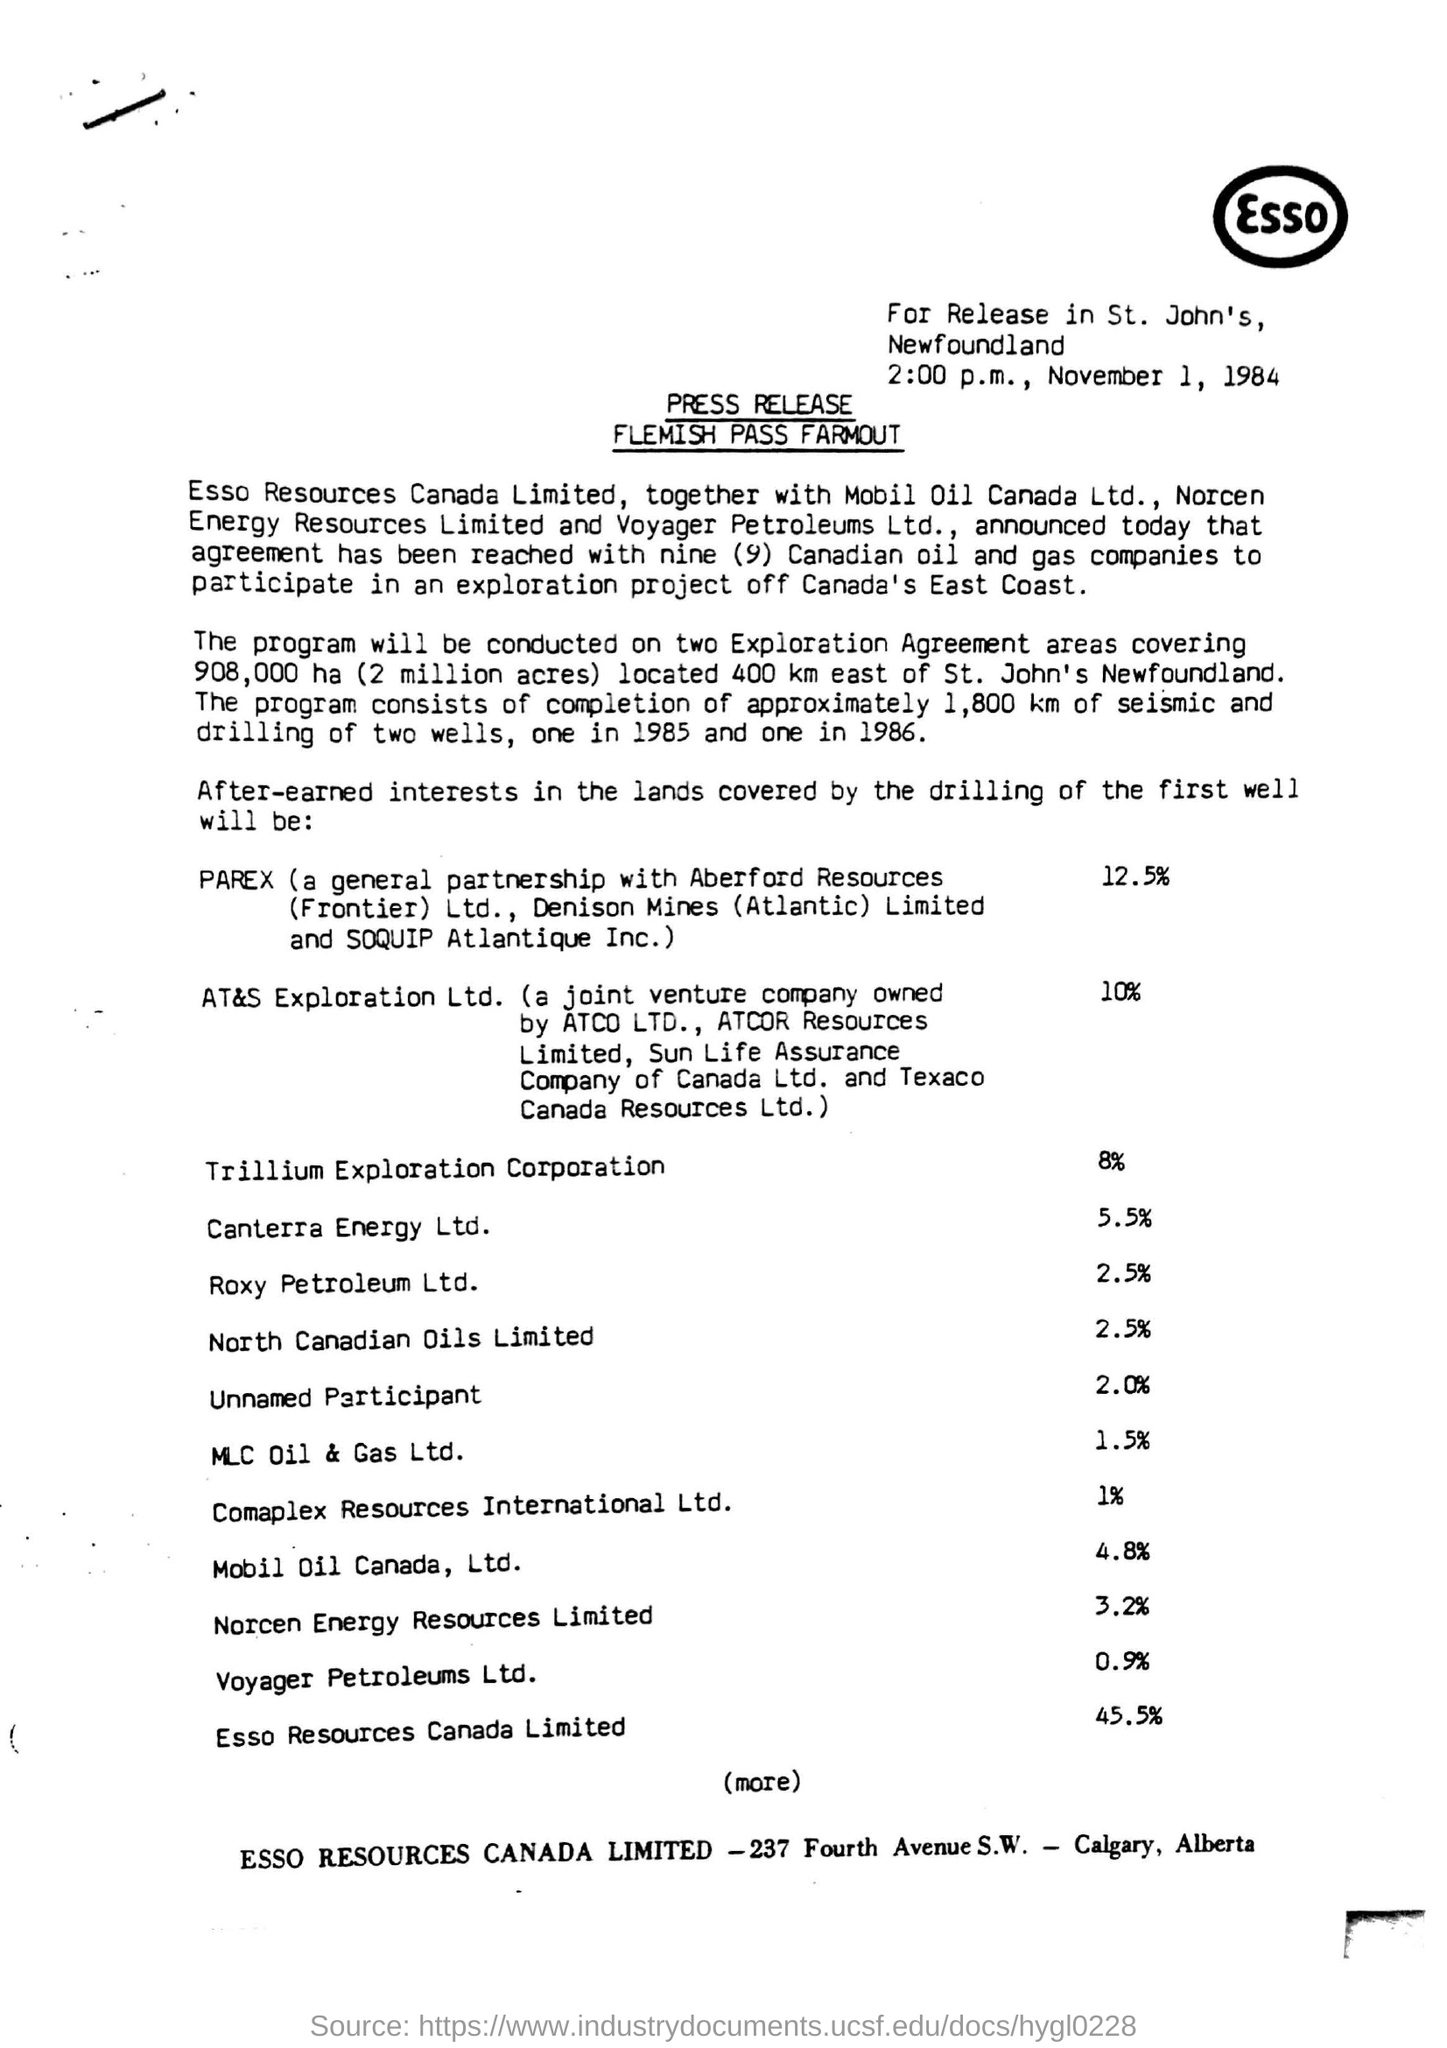What is the date mentioned in the top of the document ?
Ensure brevity in your answer.  NOVEMBER 1, 1984. What is time written in the document ?
Ensure brevity in your answer.  2:00 p.m. What is written in the top right of the document ?
Ensure brevity in your answer.  ESSO. What is the percentage of Mobil Oil Canada, Ltd ?
Offer a terse response. 4.8%. What is the percentage of Canterra Energy Ltd ?
Offer a terse response. 5.5%. What is the Highest percentage in the given list?
Your answer should be compact. 45.5%. What is the Lowest percentage in the given list?
Ensure brevity in your answer.  0.9%. 